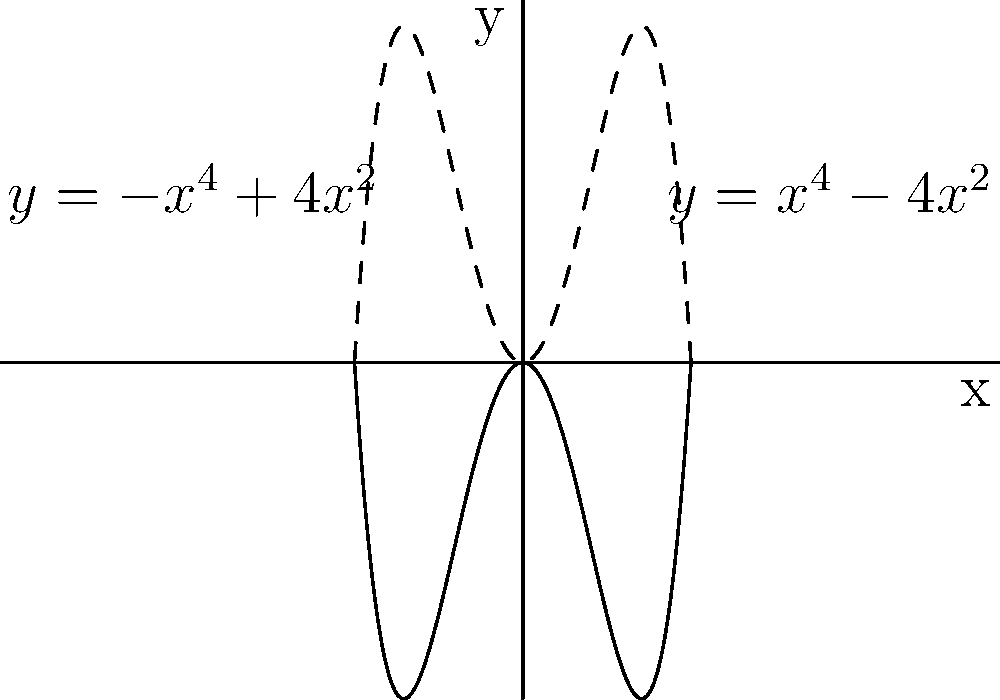In the study of Venetian architectural symmetry, consider the even polynomial functions $f(x) = x^4 - 4x^2$ and $g(x) = -x^4 + 4x^2$, which represent the curvature of certain architectural elements. Analyze the graph and determine the number of points where these functions intersect. How might this relate to the balance and harmony in Renaissance design principles? To determine the number of intersection points, we need to follow these steps:

1) First, observe that $f(x)$ and $g(x)$ are symmetric about the y-axis, as they are even functions.

2) The intersection points occur when $f(x) = g(x)$. This means:

   $x^4 - 4x^2 = -x^4 + 4x^2$

3) Simplifying this equation:

   $2x^4 - 8x^2 = 0$
   $2x^2(x^2 - 4) = 0$

4) Solving this equation:

   $x^2 = 0$ or $x^2 = 4$
   $x = 0$ or $x = \pm 2$

5) Therefore, there are three intersection points: (0,0), (2,0), and (-2,0).

6) In the context of Renaissance design, these three points of symmetry could represent the classical ideals of balance and proportion. The central point (0,0) might symbolize the focal point of a façade, while the two outer points (-2,0) and (2,0) could represent balanced architectural elements on either side.

This mathematical representation aligns with the Renaissance emphasis on symmetry and harmony in architectural design, reflecting the period's revival of classical aesthetics and rational approach to beauty.
Answer: 3 intersection points 